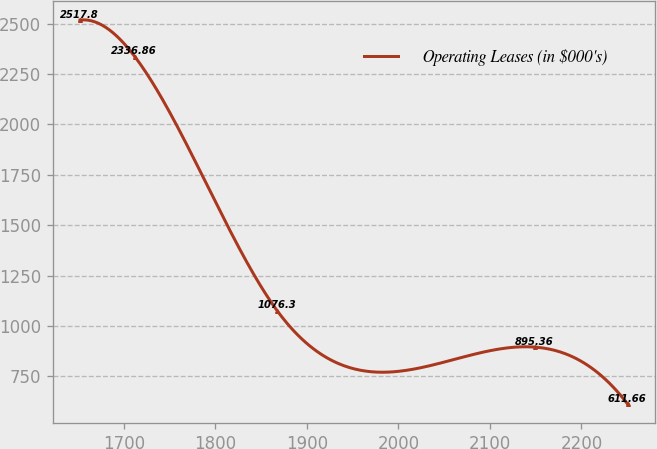Convert chart to OTSL. <chart><loc_0><loc_0><loc_500><loc_500><line_chart><ecel><fcel>Operating Leases (in $000's)<nl><fcel>1651.99<fcel>2517.8<nl><fcel>1711.86<fcel>2336.86<nl><fcel>1867.4<fcel>1076.3<nl><fcel>2148.81<fcel>895.36<nl><fcel>2250.69<fcel>611.66<nl></chart> 